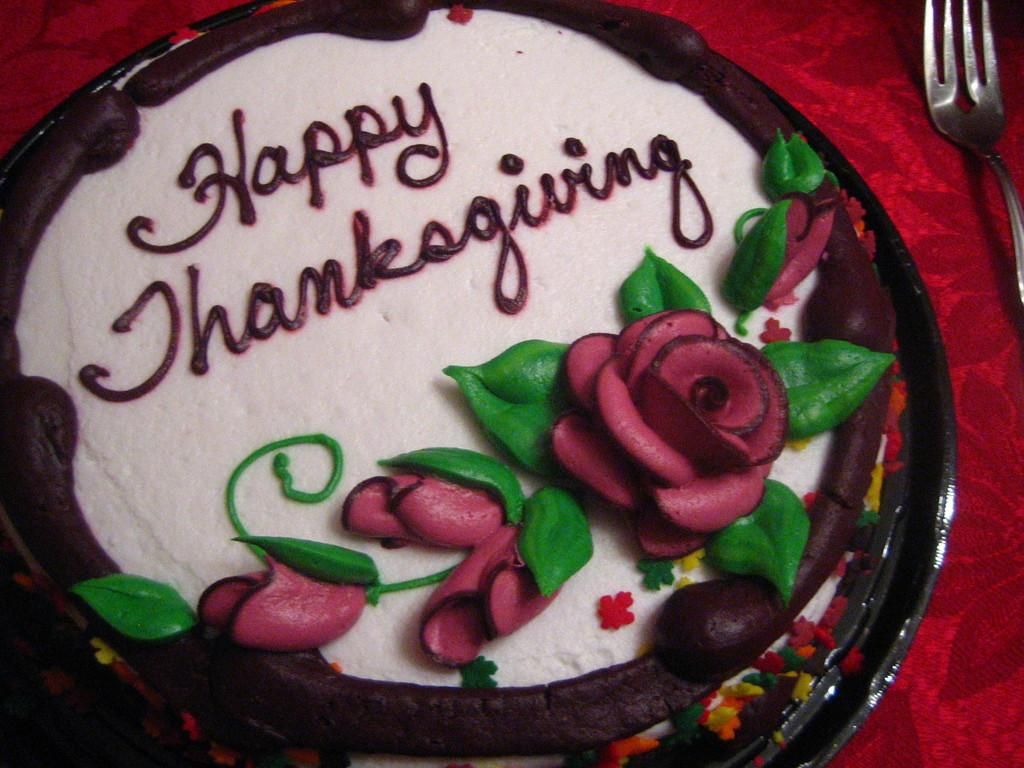What color is the cloth in the image? There is a red cloth in the image. What is placed on the red cloth? There is a cake on the red cloth. What utensil is placed with the cake on the red cloth? There is a fork on the red cloth. What is located above the cake? There is a flower above the cake. What type of vegetation is associated with the flower? There are leaves associated with the flower. What type of yarn is being used to create the geese in the image? There are no geese present in the image, and therefore no yarn or crafting materials can be observed. 